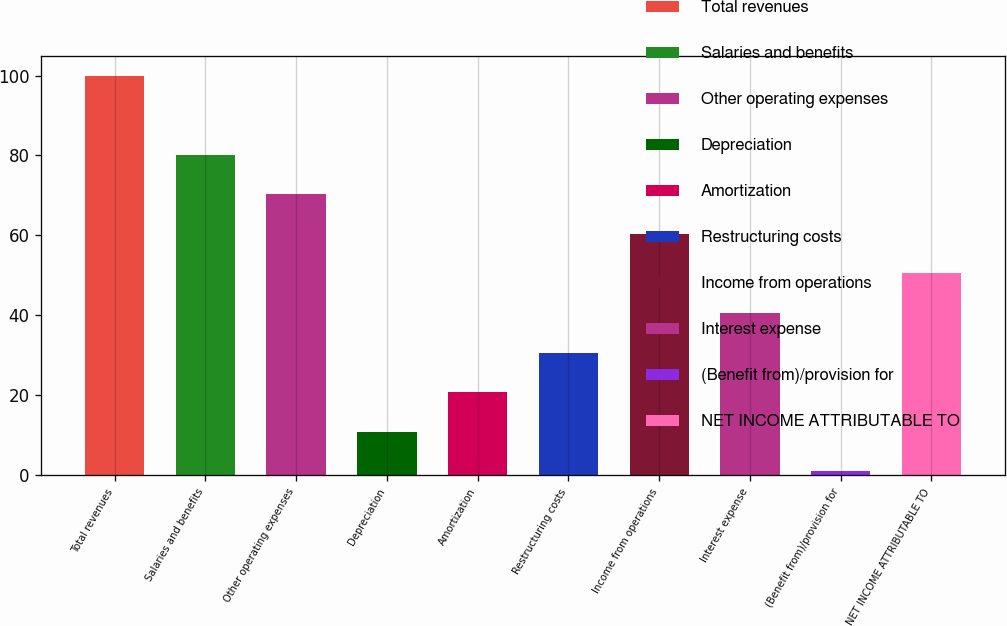<chart> <loc_0><loc_0><loc_500><loc_500><bar_chart><fcel>Total revenues<fcel>Salaries and benefits<fcel>Other operating expenses<fcel>Depreciation<fcel>Amortization<fcel>Restructuring costs<fcel>Income from operations<fcel>Interest expense<fcel>(Benefit from)/provision for<fcel>NET INCOME ATTRIBUTABLE TO<nl><fcel>100<fcel>80.2<fcel>70.3<fcel>10.9<fcel>20.8<fcel>30.7<fcel>60.4<fcel>40.6<fcel>1<fcel>50.5<nl></chart> 